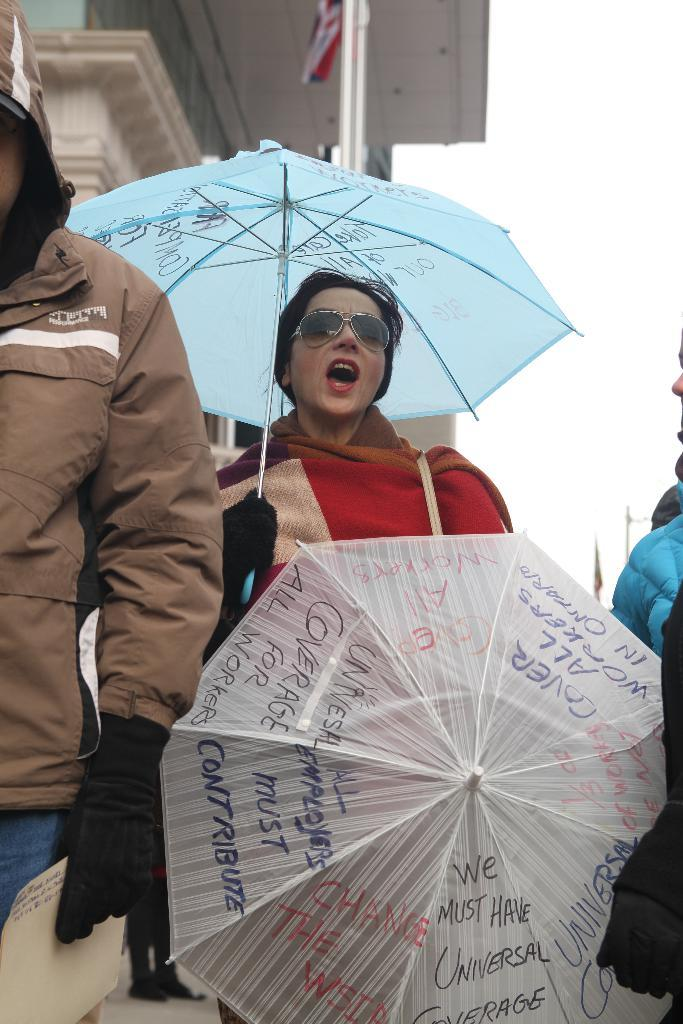What is the main subject of the image? There is a person in the image. What is the person holding in the image? The person is holding an umbrella. What protective gear is the person wearing in the image? The person is wearing goggles. What can be seen in the background of the image? There is a building visible at the top of the image. How many legs does the wren have in the image? There is no wren present in the image, so it is not possible to determine the number of legs it might have. 